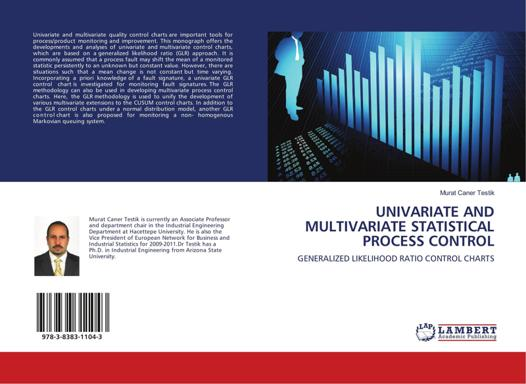Based on the image, what is the topic of the book? The topic of the book is "Univariate and Multivariate Statistical Process Control" with a focus on Generalized Likelihood Ratio Control Charts. What might be the content of this book? The book likely covers statistical concepts and methods that are applied to improve and control the quality and efficiency of processes, specifically using univariate and multivariate techniques. It probably delves into the theory and practical application of generalized likelihood ratio control charts, which are tools used to detect process changes or potential problems in data collected from various processes. This type of book would be beneficial for researchers, students, or professionals who work in fields related to manufacturing, engineering, data analysis, and quality control. 